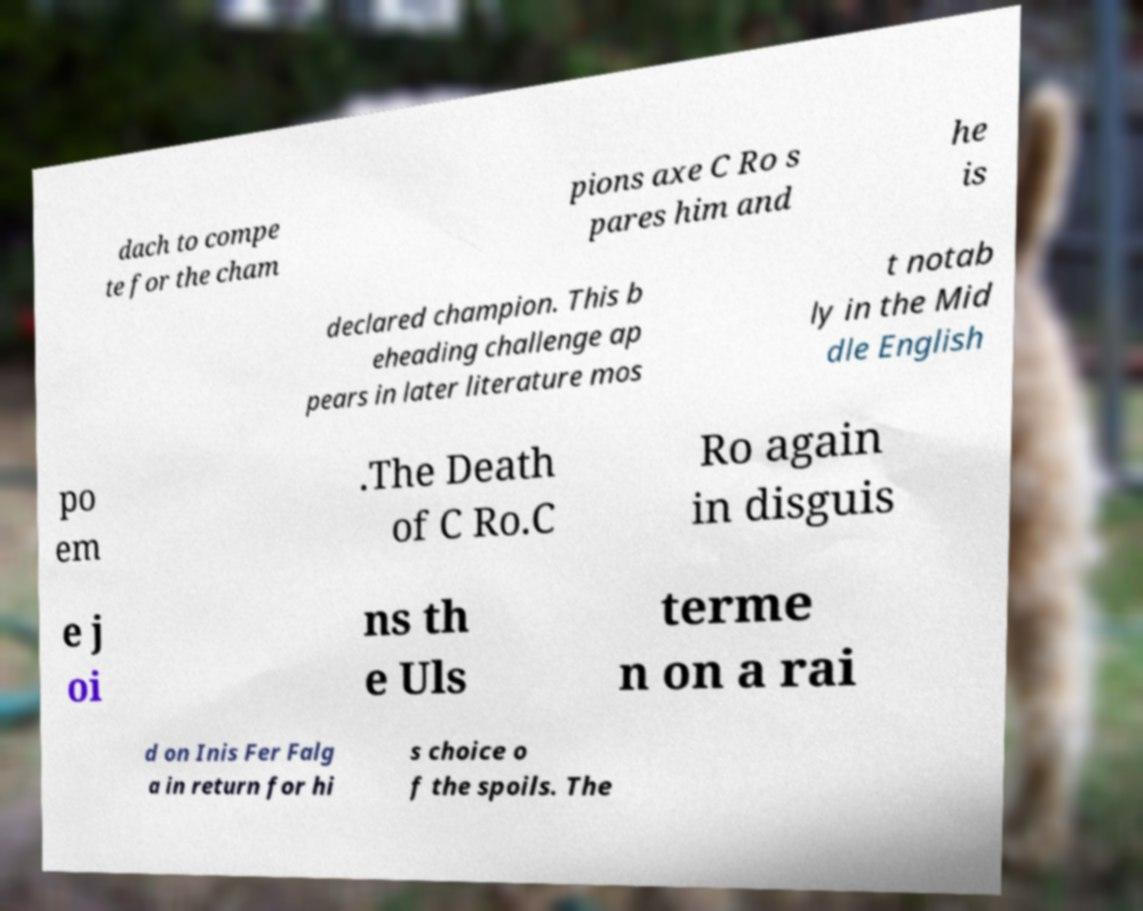What messages or text are displayed in this image? I need them in a readable, typed format. dach to compe te for the cham pions axe C Ro s pares him and he is declared champion. This b eheading challenge ap pears in later literature mos t notab ly in the Mid dle English po em .The Death of C Ro.C Ro again in disguis e j oi ns th e Uls terme n on a rai d on Inis Fer Falg a in return for hi s choice o f the spoils. The 